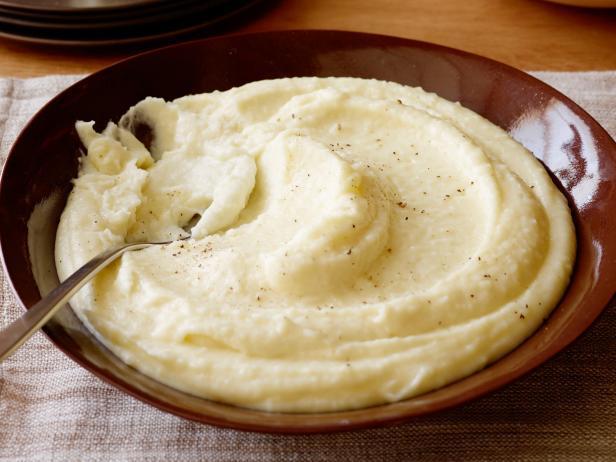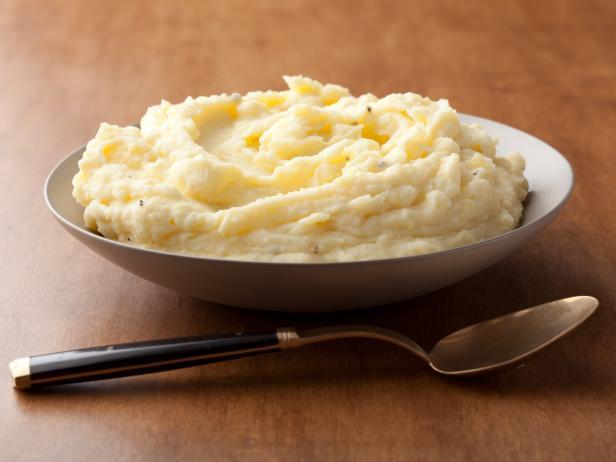The first image is the image on the left, the second image is the image on the right. Given the left and right images, does the statement "the image on the left has potatoes in a square bowl" hold true? Answer yes or no. No. 